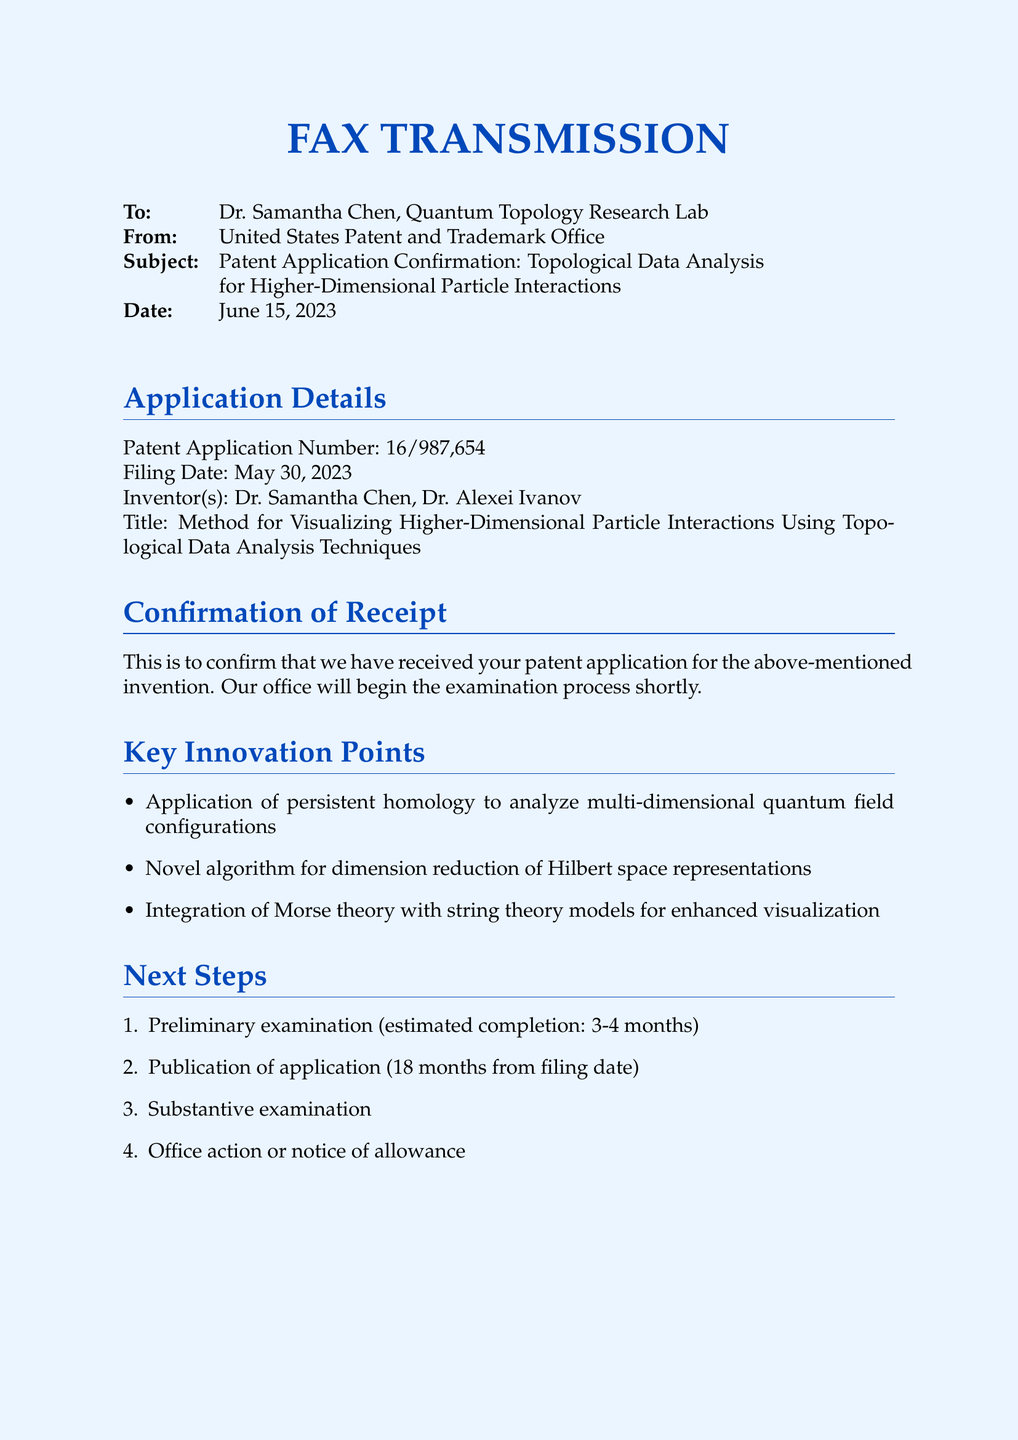What is the patent application number? The patent application number is stated in the Application Details section of the document.
Answer: 16/987,654 Who is the inventor listed in the application? The names of the inventors are mentioned in the Application Details section of the document.
Answer: Dr. Samantha Chen, Dr. Alexei Ivanov What is the title of the invention? The title is provided in the Application Details section following the inventors' names.
Answer: Method for Visualizing Higher-Dimensional Particle Interactions Using Topological Data Analysis Techniques When was the patent application filed? The filing date of the patent application is given in the Application Details section.
Answer: May 30, 2023 What is the estimated completion time for the preliminary examination? The estimated completion time for the preliminary examination is specified in the Next Steps section of the document.
Answer: 3-4 months What is one key innovation point mentioned? The key innovation points are listed under the Key Innovation Points section, which can be selected from several options.
Answer: Application of persistent homology to analyze multi-dimensional quantum field configurations What is the date of this fax transmission? The date is mentioned in the header section of the document.
Answer: June 15, 2023 What department should be contacted for queries? The relevant department to contact for queries is provided in the Additional Information section.
Answer: Quantum Physics and Mathematics Division What will happen 18 months from the filing date? The document specifies what occurs after 18 months in the Next Steps section.
Answer: Publication of application 